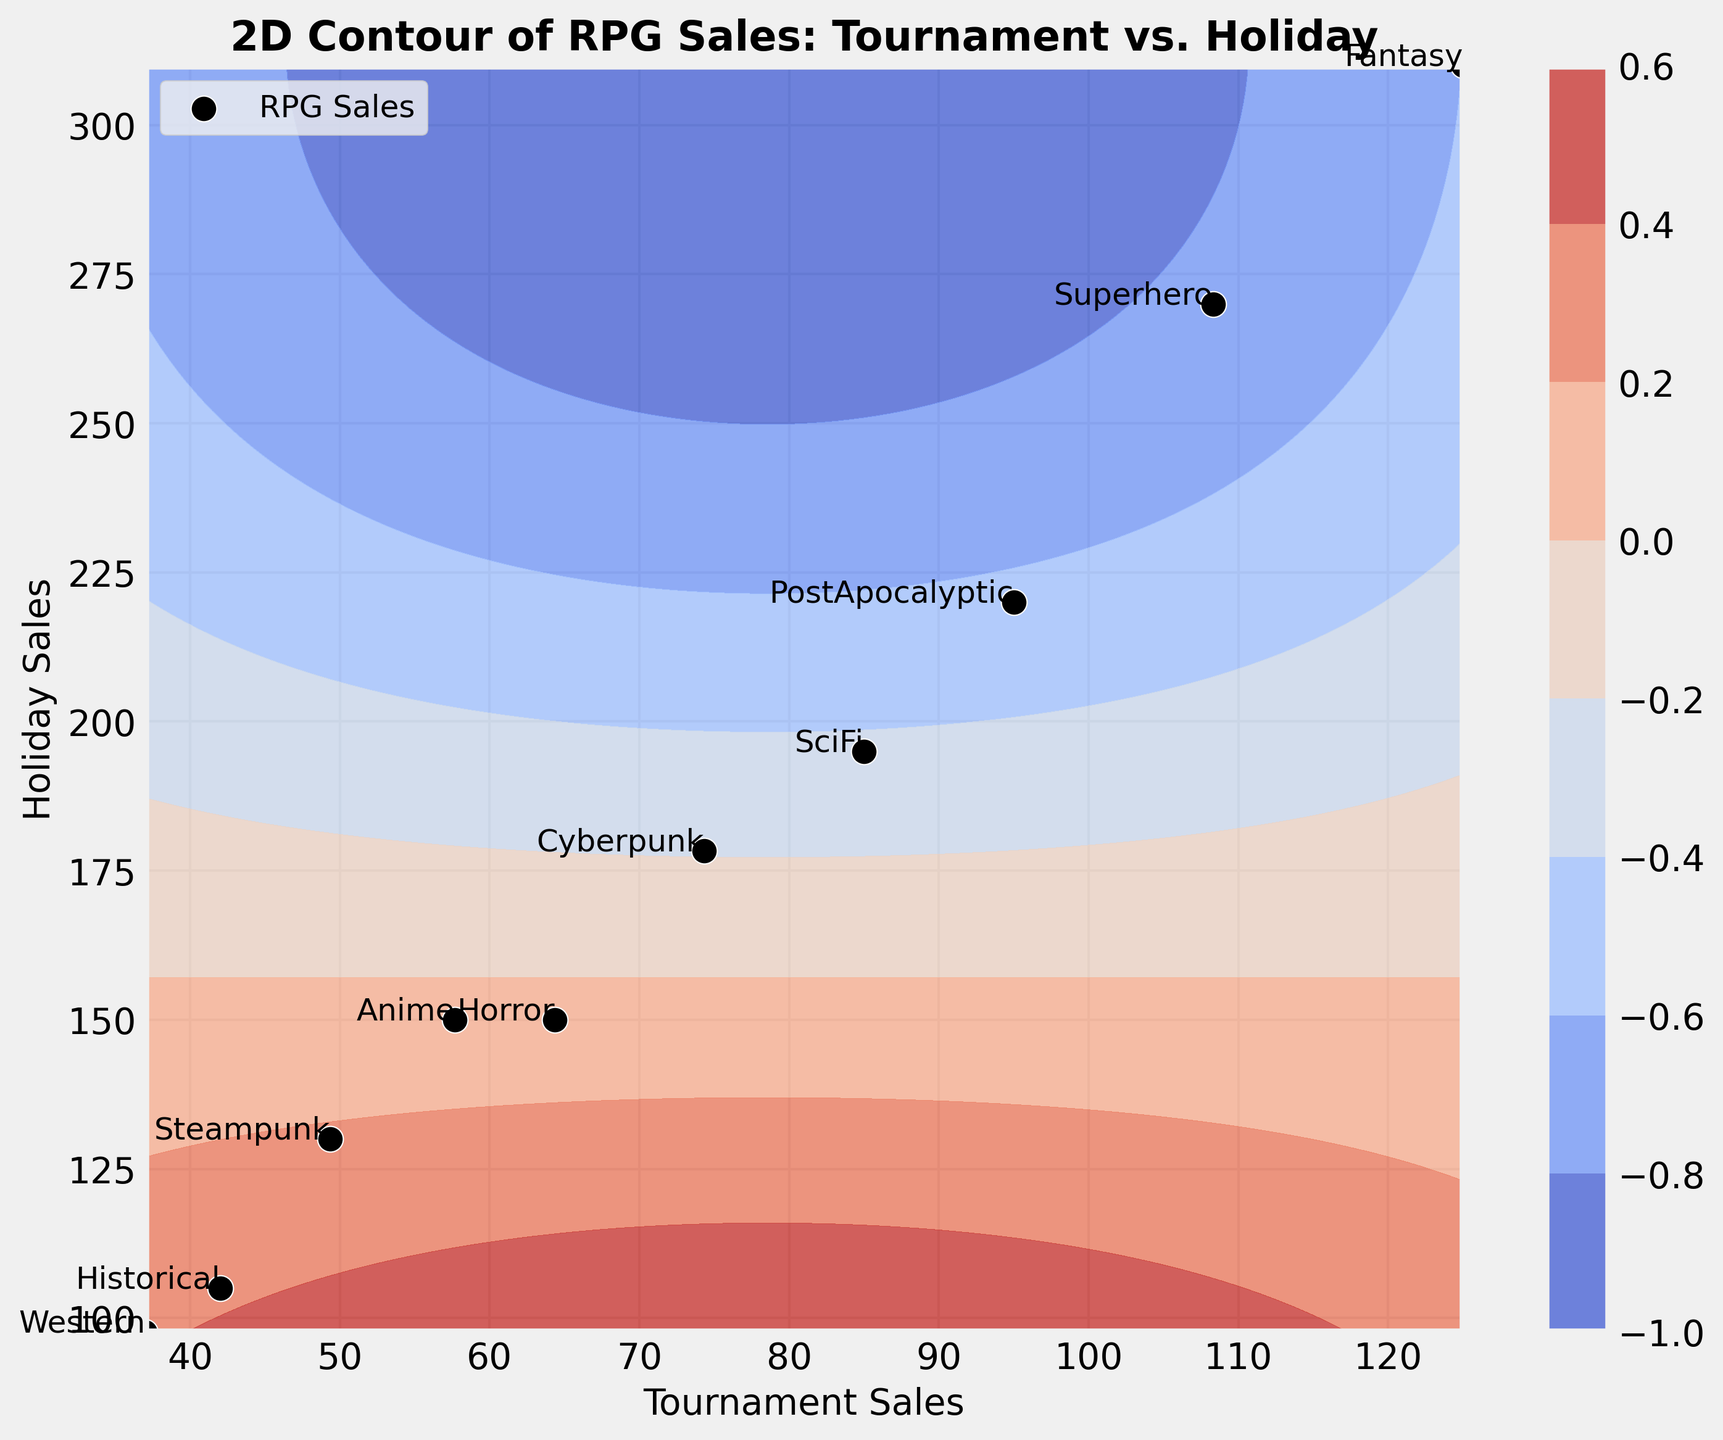Which RPG type has the highest average tournament sales? By looking at the contour plot's scatter points, the average tournament sales for each RPG type are visible. The Fantasy RPG type has the highest position on the tournament sales axis.
Answer: Fantasy Which RPG type sees the smallest difference in sales between tournaments and holidays? To find the smallest difference, look for the RPG type where the tournament and holiday sales points are closest to each other. Western has the smallest vertical distance between its coordinates.
Answer: Western How do tournament sales for Cyberpunk compare to those for Steampunk? Compare the horizontal positions of Cyberpunk and Steampunk on the scatter plot. Cyberpunk has higher tournament sales points than Steampunk.
Answer: Cyberpunk What is the approximate range of holiday sales in the data? Observing the vertical axis where the holiday sales data points are scattered, the lowest and highest points are from Historical (around 100) to Fantasy (around 320). So the range is from approximately 100 to 320.
Answer: 100 to 320 Which RPG type is most correlated with high holiday sales but not the highest tournament sales? Identify the RPG types with high holiday sales positions but not the peak in tournament sales. Superhero has high holiday sales but is lower on tournament sales compared to Fantasy.
Answer: Superhero Which RPG type has just slightly higher holiday sales than Western? Find the holiday sales of Western and look for the next higher position. Historical has holiday sales slightly higher than Western.
Answer: Historical Are tournament sales generally higher or lower than holiday sales for RPGs in this data set? By examining the scatter points, the majority of the RPG types lie above the diagonal x=y line, indicating that holiday sales are generally higher.
Answer: Higher How many RPG types have average holiday sales above 200? Look for scatter points with holiday sales above 200 on the vertical axis. Fantasy, SciFi, PostApocalyptic, and Superhero hit this criterion.
Answer: 4 Does any RPG type have both tournament and holiday sales below 50? Check the scatter plot to see if any RPG type is below 50 on both axes. No RPG type fulfills this condition.
Answer: No 